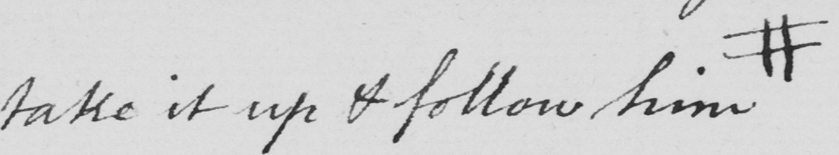What text is written in this handwritten line? take it up & follow him # 